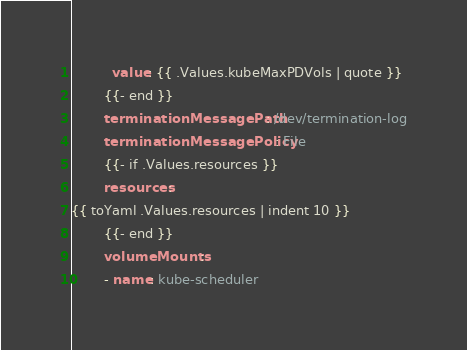Convert code to text. <code><loc_0><loc_0><loc_500><loc_500><_YAML_>          value: {{ .Values.kubeMaxPDVols | quote }}
        {{- end }}
        terminationMessagePath: /dev/termination-log
        terminationMessagePolicy: File
        {{- if .Values.resources }}
        resources:
{{ toYaml .Values.resources | indent 10 }}
        {{- end }}
        volumeMounts:
        - name: kube-scheduler</code> 